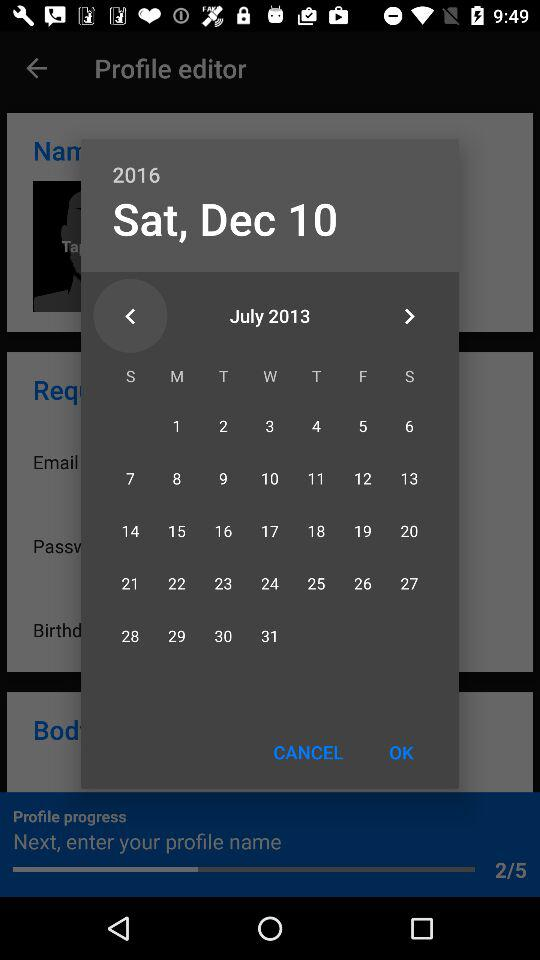Which month and year in the calendar are currently displayed? In the calendar, the currently displayed months are December and July, and the years are 2016 and 2013. 